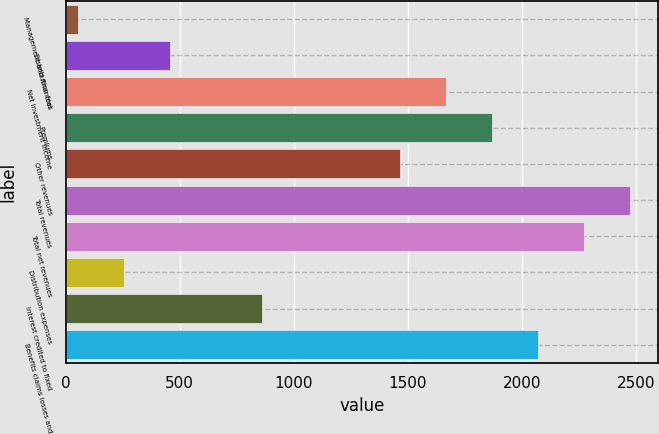Convert chart. <chart><loc_0><loc_0><loc_500><loc_500><bar_chart><fcel>Management and financial<fcel>Distribution fees<fcel>Net investment income<fcel>Premiums<fcel>Other revenues<fcel>Total revenues<fcel>Total net revenues<fcel>Distribution expenses<fcel>Interest credited to fixed<fcel>Benefits claims losses and<nl><fcel>56<fcel>458.8<fcel>1667.2<fcel>1868.6<fcel>1465.8<fcel>2472.8<fcel>2271.4<fcel>257.4<fcel>861.6<fcel>2070<nl></chart> 